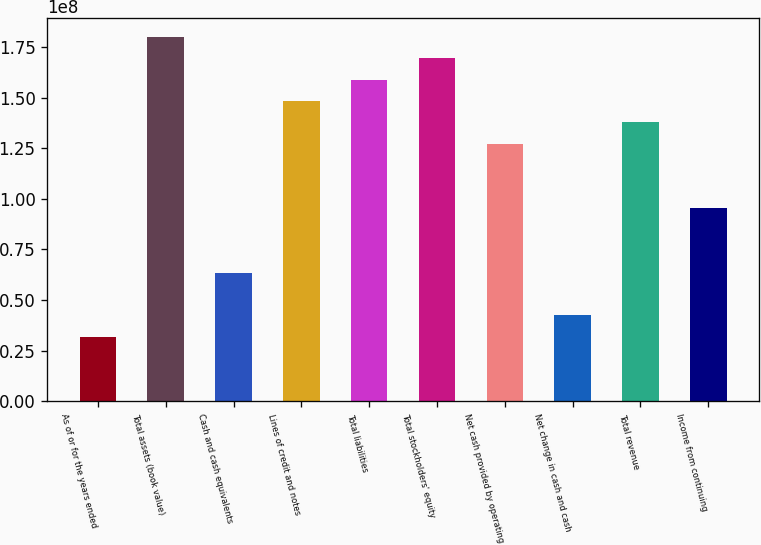Convert chart to OTSL. <chart><loc_0><loc_0><loc_500><loc_500><bar_chart><fcel>As of or for the years ended<fcel>Total assets (book value)<fcel>Cash and cash equivalents<fcel>Lines of credit and notes<fcel>Total liabilities<fcel>Total stockholders' equity<fcel>Net cash provided by operating<fcel>Net change in cash and cash<fcel>Total revenue<fcel>Income from continuing<nl><fcel>3.17828e+07<fcel>1.80103e+08<fcel>6.35656e+07<fcel>1.4832e+08<fcel>1.58914e+08<fcel>1.69508e+08<fcel>1.27131e+08<fcel>4.23771e+07<fcel>1.37726e+08<fcel>9.53484e+07<nl></chart> 